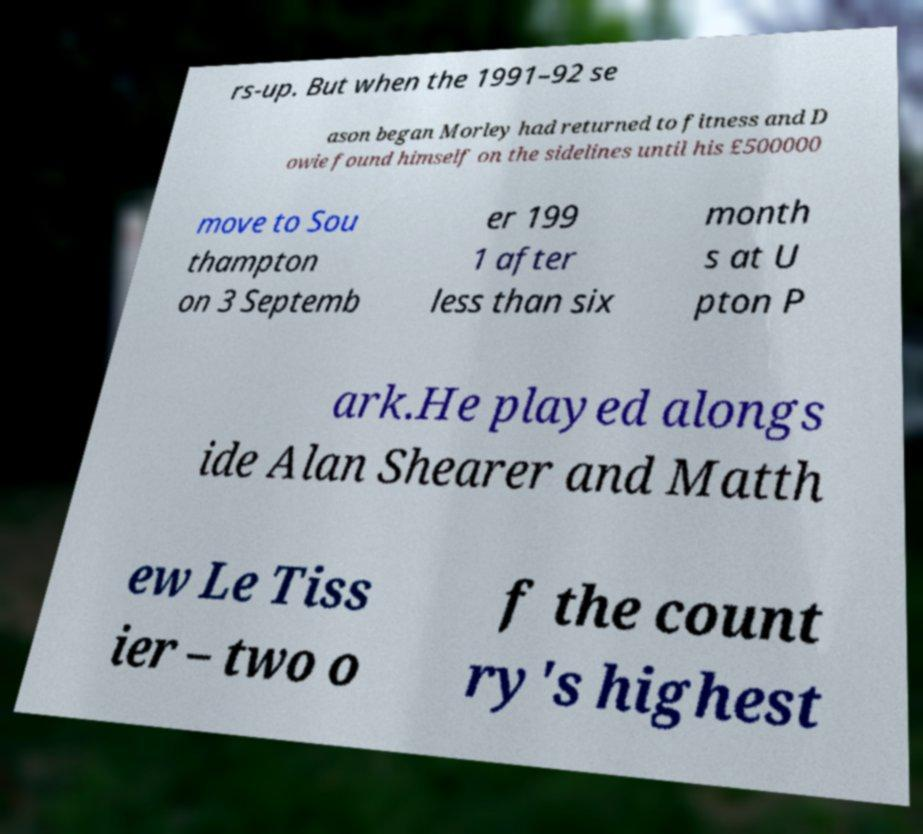Can you read and provide the text displayed in the image?This photo seems to have some interesting text. Can you extract and type it out for me? rs-up. But when the 1991–92 se ason began Morley had returned to fitness and D owie found himself on the sidelines until his £500000 move to Sou thampton on 3 Septemb er 199 1 after less than six month s at U pton P ark.He played alongs ide Alan Shearer and Matth ew Le Tiss ier – two o f the count ry's highest 